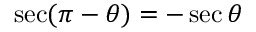<formula> <loc_0><loc_0><loc_500><loc_500>\sec ( \pi - \theta ) = - \sec \theta</formula> 